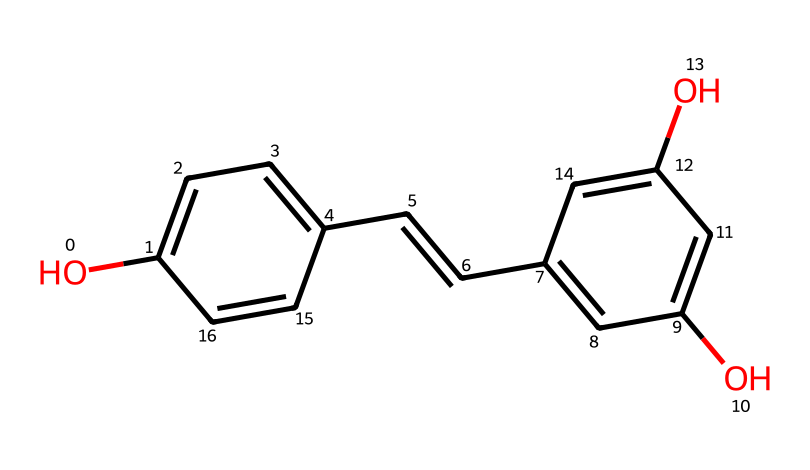How many hydroxyl groups are present in this chemical structure? The chemical structure indicates the presence of hydroxyl groups which are shown as -OH functional groups. Upon examining the structure, there are two -OH groups located on the aromatic ring.
Answer: two What is the IUPAC name of this compound? The chemical structure provided corresponds to a well-known compound. Evaluating the structure shows that it consists of two aromatic rings connected by a double bond with hydroxyl groups, leading to the IUPAC name: 3,5-dihydroxy-1,2-diphenylethene.
Answer: 3,5-dihydroxy-1,2-diphenylethene How many carbon atoms are present in the structure? To determine the number of carbon atoms, we count all the vertices and ends of the lines that represent carbon atoms in the SMILES notation. The structure reveals a total of 14 carbon atoms.
Answer: fourteen What type of chemical is this compound categorized as? The chemical structure and the presence of hydroxyl groups indicate that this compound acts as an antioxidant. Additionally, it is a phenolic compound characterized by its ability to scavenge free radicals.
Answer: antioxidant Which functional groups are present in this chemical structure? Analyzing the provided structure reveals the presence of hydroxyl (-OH) groups linked to aromatic carbons. These -OH groups are indicative of phenolic compounds, contributing to the compound's antioxidant properties.
Answer: hydroxyl groups 